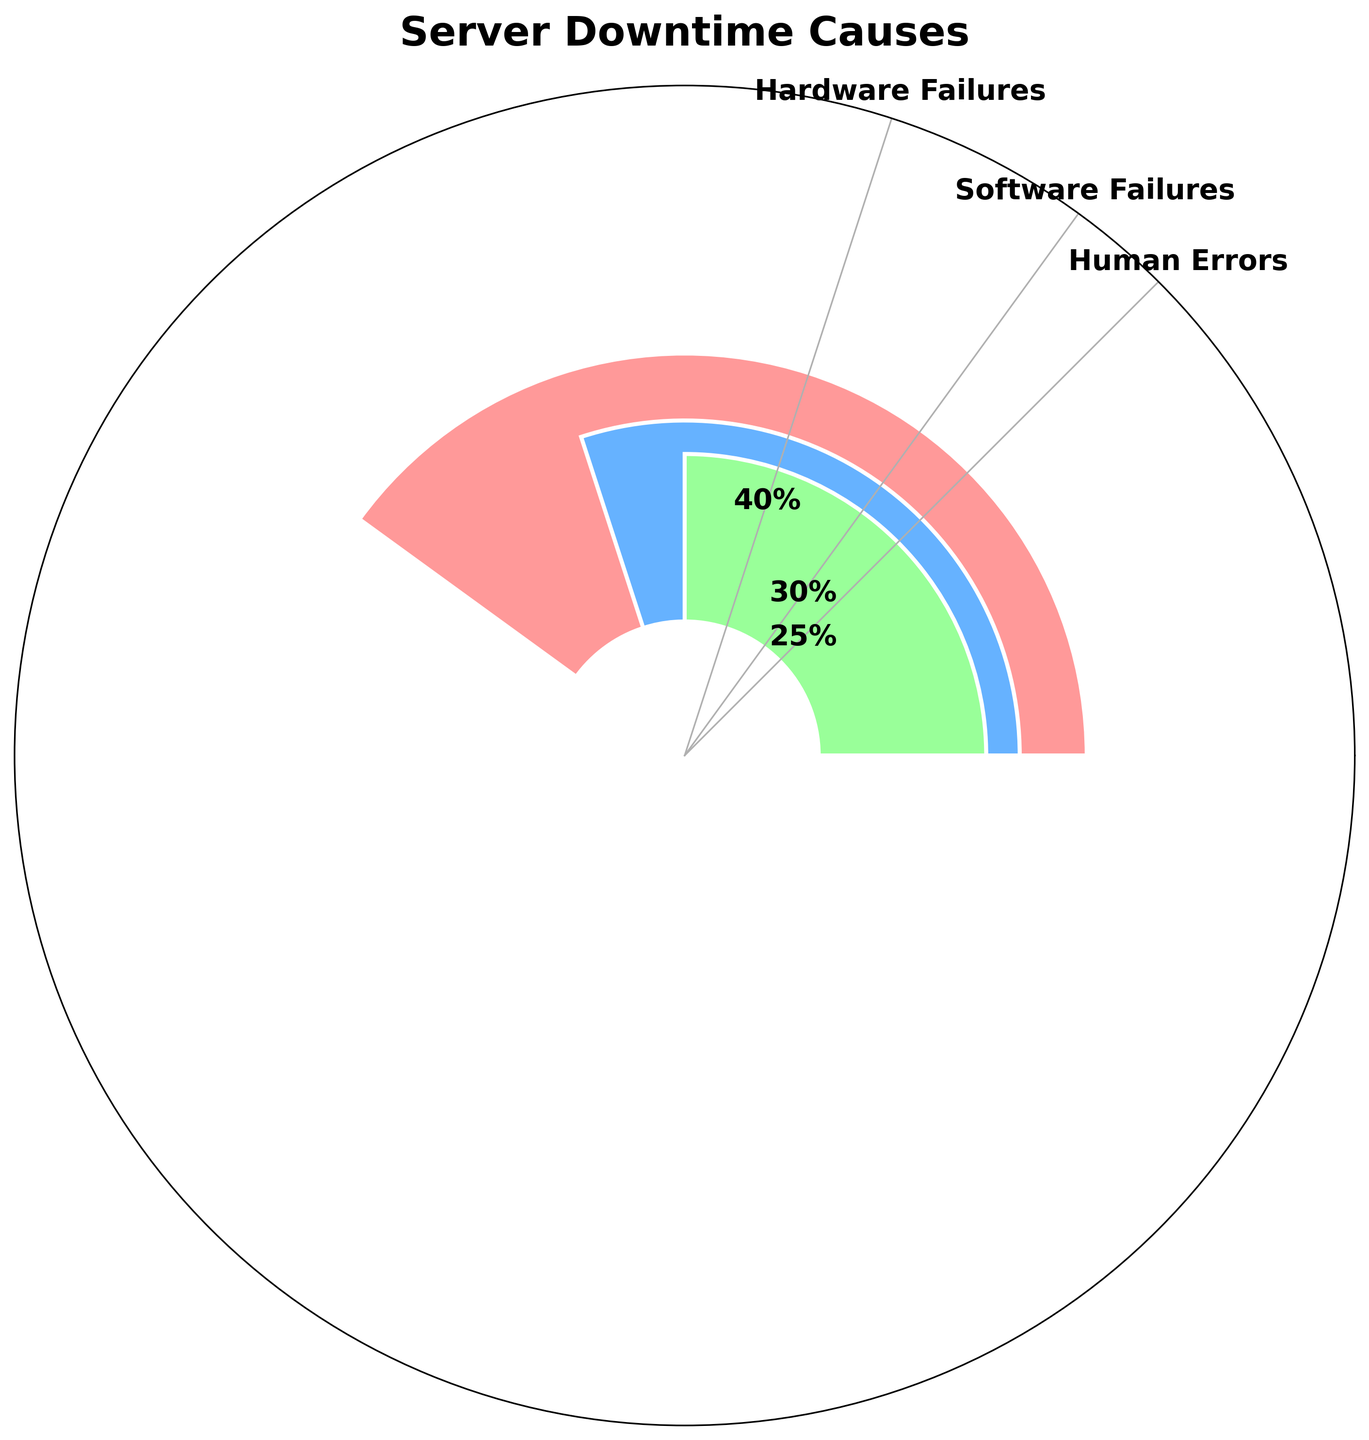What is the title of the chart? The chart's title is written at the top and provides the main subject of the figure.
Answer: Server Downtime Causes Which category has the highest percentage? By looking at the heights of the bars, the category with the tallest bar has the highest percentage.
Answer: Hardware Failures What is the combined percentage of Software Failures and Human Errors? Sum the percentages of Software Failures (30%) and Human Errors (25%). 30% + 25% = 55%.
Answer: 55% How does the percentage of Hardware Failures compare to Human Errors? Compare the percentages directly from the chart: Hardware Failures (40%) is greater than Human Errors (25%).
Answer: Hardware Failures is greater How many categories are represented in the chart? Count the distinct bars or labels in the chart. There are 3 main categories mentioned (excluding 'Other').
Answer: 3 What can we infer from the color coding in the chart? Each bar is distinctly colored, which helps differentiate between categories. Observe the legend or directly infer the associations.
Answer: Different colors represent different categories What is the average percentage of all categories shown in the chart? Sum the percentages of all categories (40% + 30% + 25%) and divide by the number of categories (3). (40 + 30 + 25) / 3 = 31.67%.
Answer: 31.67% Which category is represented by the green bar? Identify the color of the third bar which is green, corresponding to the labels in the chart.
Answer: Human Errors Is there a significant difference between the highest and the lowest percentages shown in the chart? Calculate the difference between the highest percentage (Hardware Failures: 40%) and the lowest percentage among main categories (Human Errors: 25%). 40% - 25% = 15%.
Answer: Yes, 15% How are the percentage labels presented in the chart? Describe the position or format of percentage labels based on their appearance in the figure.
Answer: Centered on top of each bar 